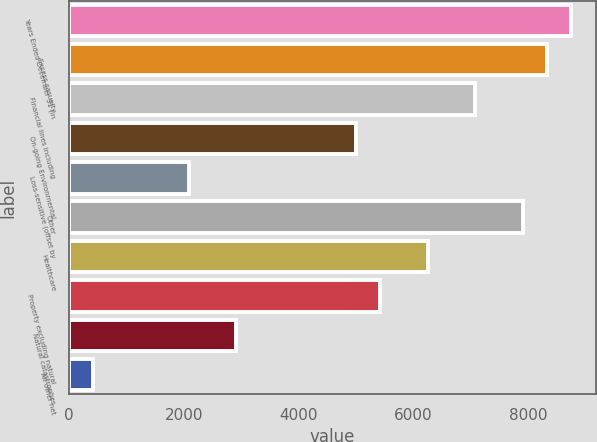Convert chart to OTSL. <chart><loc_0><loc_0><loc_500><loc_500><bar_chart><fcel>Years Ended December 31 (in<fcel>Excess casualty<fcel>Financial lines including<fcel>On-going Environmental<fcel>Loss-sensitive (offset by<fcel>Other<fcel>Healthcare<fcel>Property excluding natural<fcel>Natural catastrophes<fcel>All other net<nl><fcel>8747.3<fcel>8331<fcel>7082.1<fcel>5000.6<fcel>2086.5<fcel>7914.7<fcel>6249.5<fcel>5416.9<fcel>2919.1<fcel>421.3<nl></chart> 